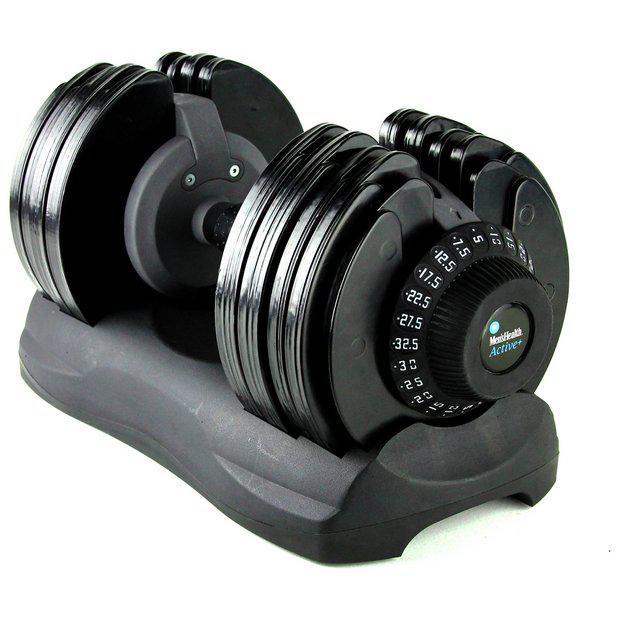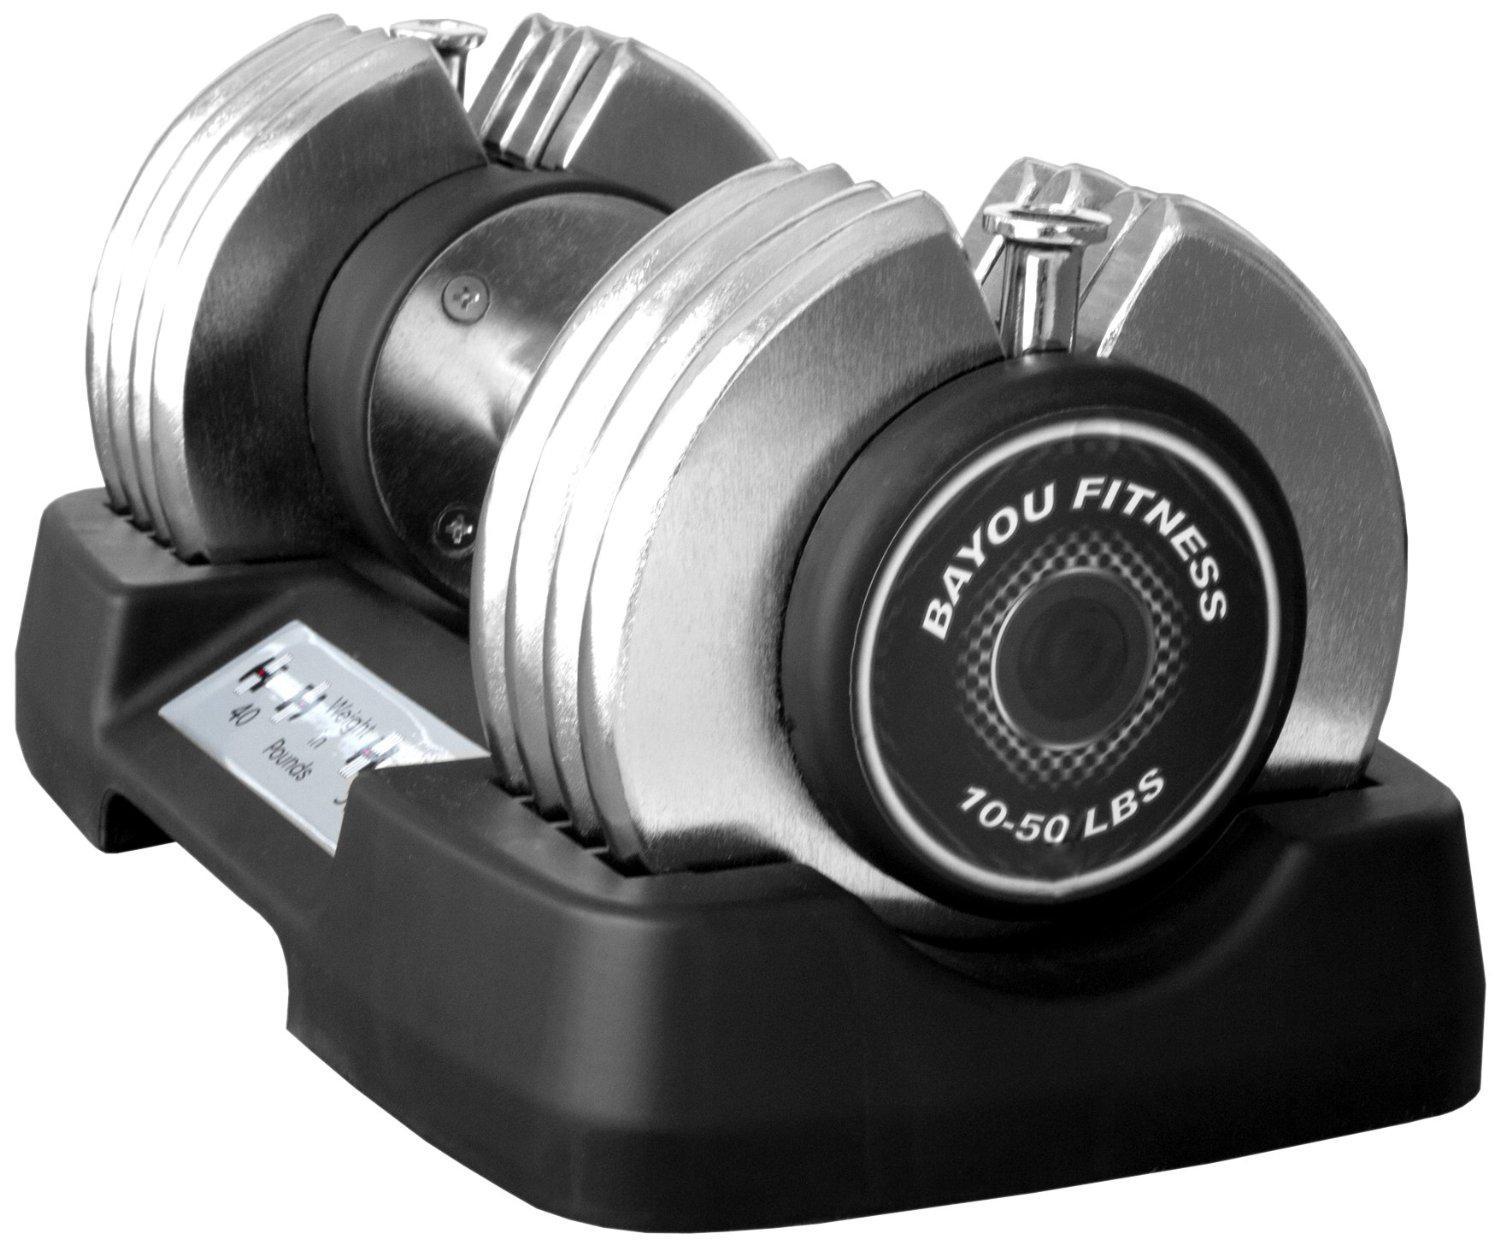The first image is the image on the left, the second image is the image on the right. Evaluate the accuracy of this statement regarding the images: "There are exactly three weights with no bars sticking out of them.". Is it true? Answer yes or no. No. The first image is the image on the left, the second image is the image on the right. Assess this claim about the two images: "There are 3 dumbbells, and all of them are on storage trays.". Correct or not? Answer yes or no. No. 